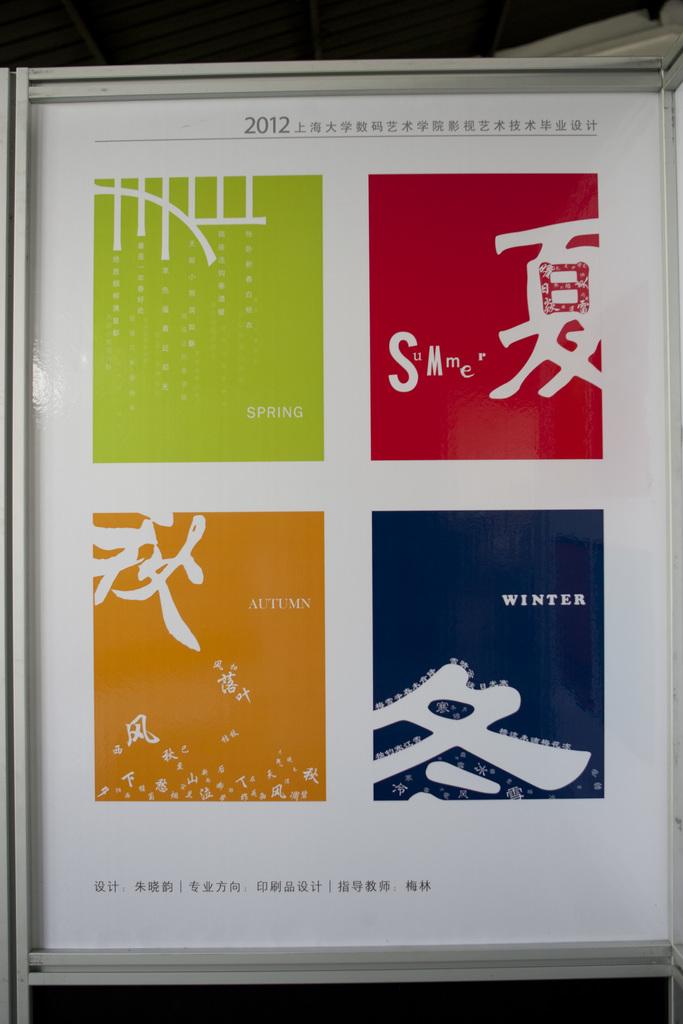What year is on the advert?
Keep it short and to the point. 2012. 